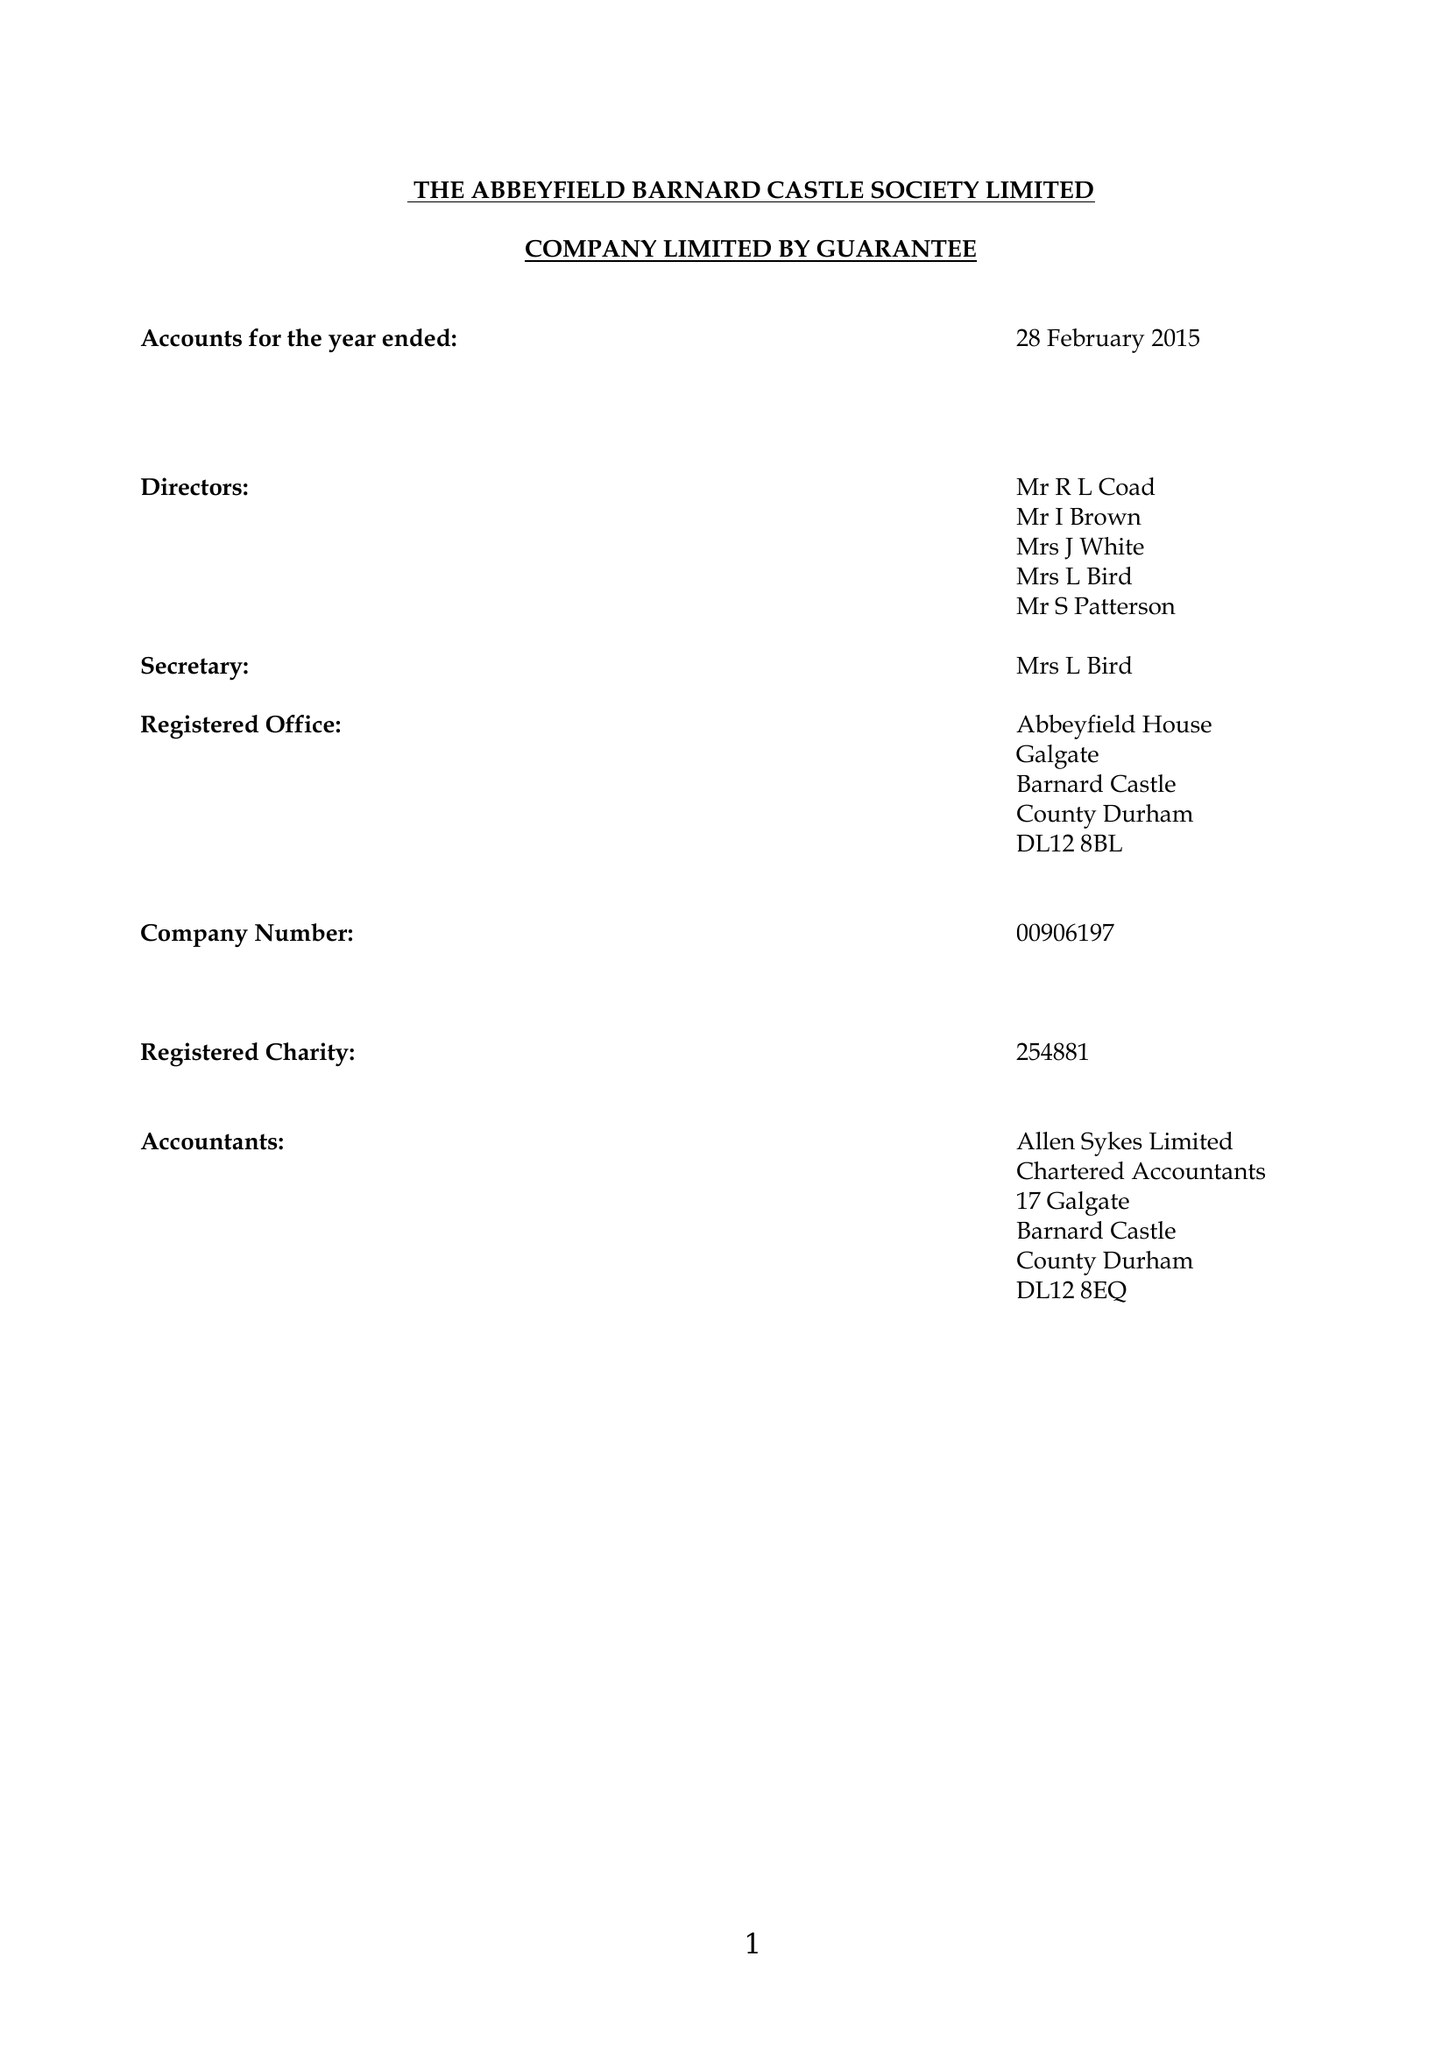What is the value for the charity_number?
Answer the question using a single word or phrase. 254881 